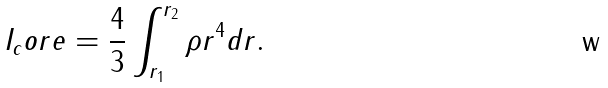Convert formula to latex. <formula><loc_0><loc_0><loc_500><loc_500>I _ { c } o r e = \frac { 4 } { 3 } \int _ { r _ { 1 } } ^ { r _ { 2 } } \rho r ^ { 4 } d r .</formula> 